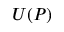<formula> <loc_0><loc_0><loc_500><loc_500>U ( P )</formula> 